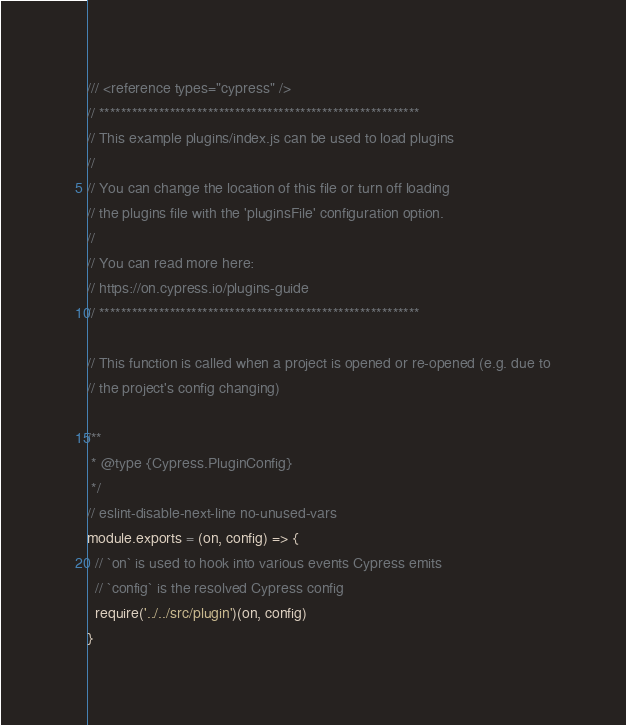Convert code to text. <code><loc_0><loc_0><loc_500><loc_500><_JavaScript_>/// <reference types="cypress" />
// ***********************************************************
// This example plugins/index.js can be used to load plugins
//
// You can change the location of this file or turn off loading
// the plugins file with the 'pluginsFile' configuration option.
//
// You can read more here:
// https://on.cypress.io/plugins-guide
// ***********************************************************

// This function is called when a project is opened or re-opened (e.g. due to
// the project's config changing)

/**
 * @type {Cypress.PluginConfig}
 */
// eslint-disable-next-line no-unused-vars
module.exports = (on, config) => {
  // `on` is used to hook into various events Cypress emits
  // `config` is the resolved Cypress config
  require('../../src/plugin')(on, config)
}
</code> 